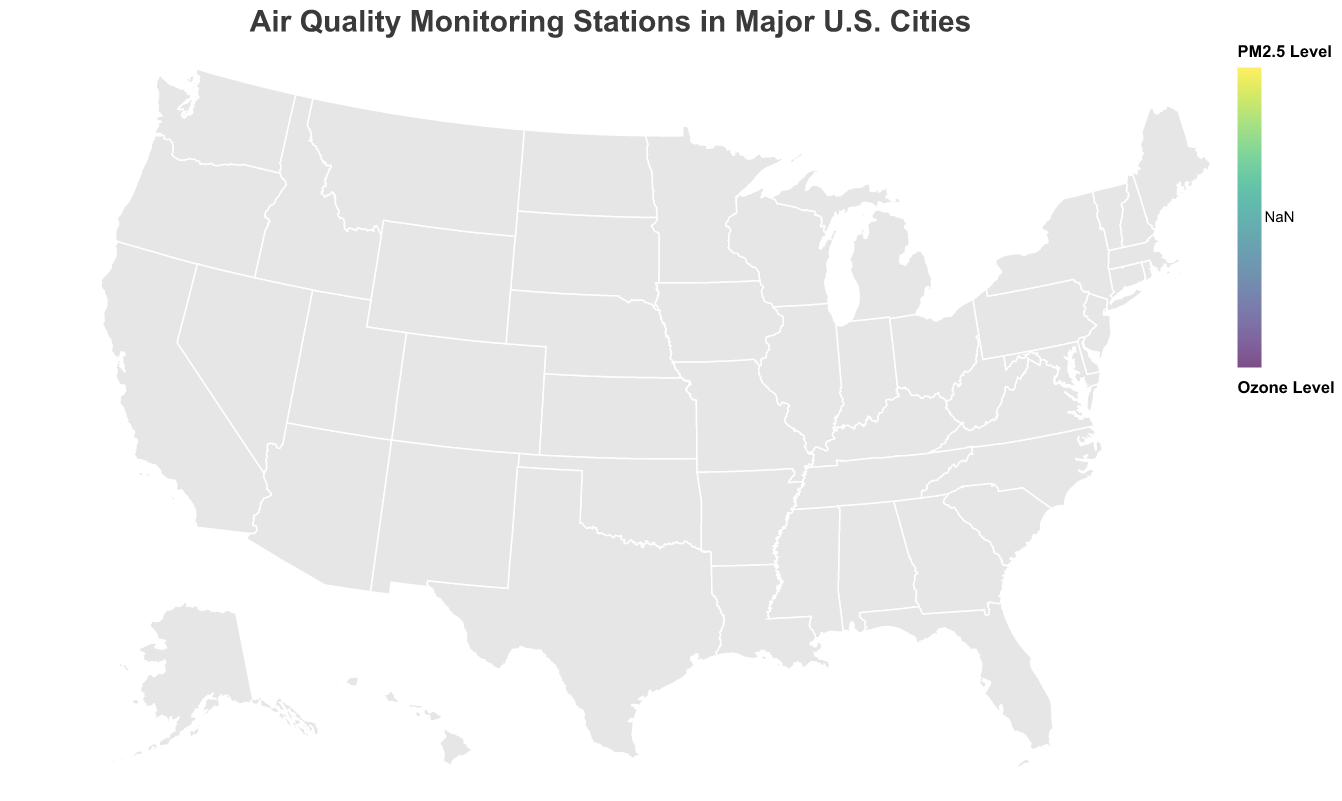What is the title of the figure? The title is prominently displayed at the top of the figure in a larger font size.
Answer: Air Quality Monitoring Stations in Major U.S. Cities Which city has the highest PM2.5 level reported? By looking at the color gradient, the city with the darkest shade indicating the highest PM2.5 level can be identified.
Answer: Los Angeles How many monitoring stations are there in San Francisco? By counting the number of circles placed in San Francisco's geographic location on the map, we can determine the number.
Answer: 2 Which monitoring station reports the highest NO2 level? By examining the NO2 levels in the tooltip details for each station, we can identify the station with the highest value.
Answer: Downtown LA In which city is the "Downtown Houston" station located, and what are its pollution levels? By locating the circle named "Downtown Houston," we can refer to the tooltip for detailed pollution levels.
Answer: Houston, PM2.5: 20.1, Ozone: 0.070, NO2: 35 Compare the Ozone levels between the stations in Phoenix. Which one has higher levels? By checking the size of the circles and the tooltip details for "Central Phoenix" and "Mesa," we compare their Ozone levels.
Answer: Central Phoenix What is the average PM2.5 level of the monitoring stations in New York? By adding the PM2.5 levels of both New York stations and dividing by the number of stations: (18.5 + 22.3) / 2 = 20.4
Answer: 20.4 Which two cities have the closest reported PM2.5 levels for their monitoring stations, and what are those levels? By visually comparing the color gradients and confirming with the tooltip values, we see that New York (Manhattan Central) and Philadelphia (Center City) are closest: 18.5 and 16.3
Answer: New York (Manhattan Central) and Philadelphia (Center City), 18.5 and 16.3 Which station in Chicago shows a higher NO2 level? Provide the NO2 levels for both stations. By examining the tooltip for "Loop District" and "O'Hare Airport" stations, we identify which has higher NO2 levels and enumerate both values.
Answer: Loop District, NO2: 30; O'Hare Airport, NO2: 25 What is the range of Ozone levels reported across all stations in the figure? By finding the maximum and minimum Ozone levels from the tooltip details of all stations, we calculate the range by subtracting the smallest value from the largest one. Max: 0.080, Min: 0.035, therefore, Range: 0.080 - 0.035 = 0.045
Answer: 0.045 